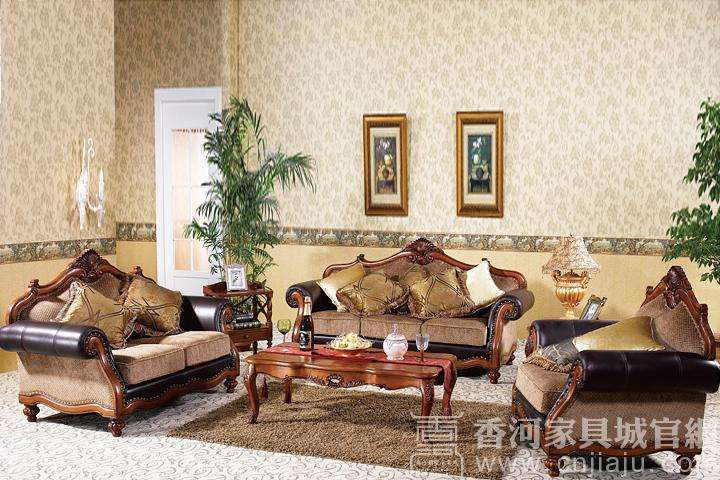What style does the furniture in this image represent? The furniture in this image represents a classic, possibly Baroque-inspired style, characterized by ornate carvings, curved lines, and luxurious fabrics. This elegant aesthetic is often associated with sophistication and an appreciation for traditional craftsmanship. 